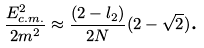<formula> <loc_0><loc_0><loc_500><loc_500>\frac { E _ { c . m . } ^ { 2 } } { 2 m ^ { 2 } } \approx \frac { ( 2 - l _ { 2 } ) } { 2 N } ( 2 - \sqrt { 2 } ) \text {.}</formula> 